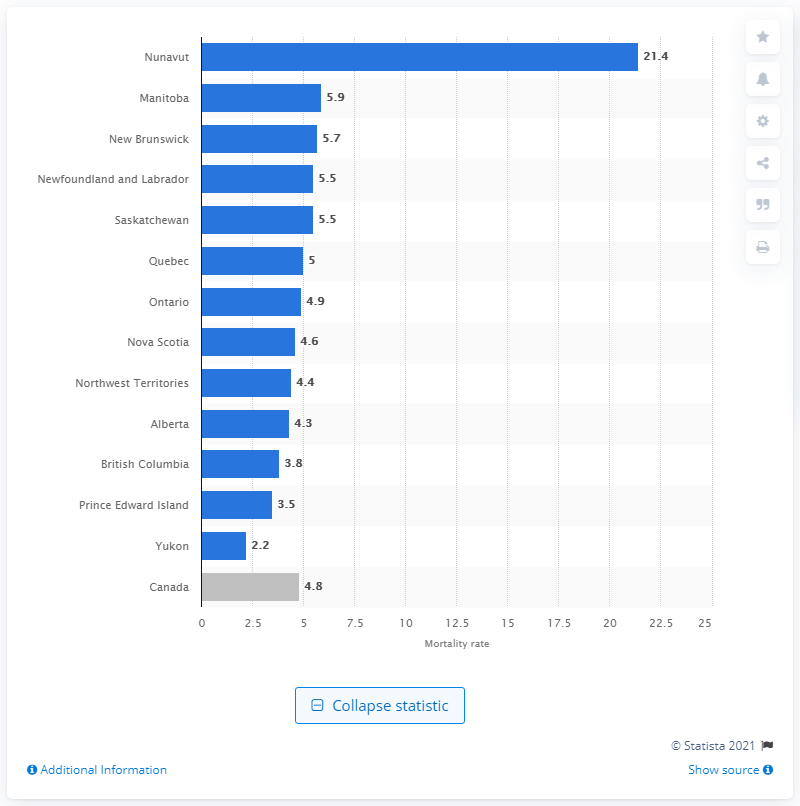Give some essential details in this illustration. In Nunavut in 2012, there were 21.4 infant deaths per 1,000 live births. 